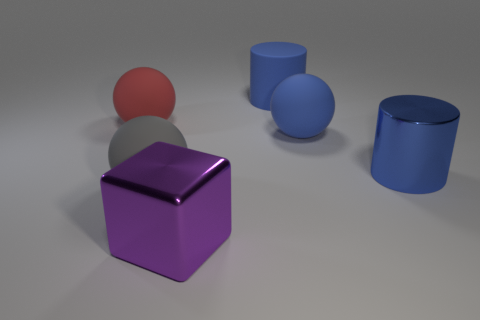Is there anything else that has the same shape as the big purple thing?
Your answer should be very brief. No. Are there fewer matte objects that are behind the big red matte object than large cubes in front of the big purple metallic thing?
Ensure brevity in your answer.  No. What number of blue cylinders are behind the big blue rubber ball?
Offer a very short reply. 1. There is a big shiny object behind the purple shiny object; is its shape the same as the large red rubber object that is behind the purple object?
Provide a short and direct response. No. What number of other objects are the same color as the metallic cylinder?
Provide a succinct answer. 2. There is a sphere that is in front of the big blue cylinder that is on the right side of the large sphere that is on the right side of the purple cube; what is its material?
Provide a short and direct response. Rubber. What material is the sphere on the right side of the blue cylinder that is left of the shiny cylinder?
Provide a succinct answer. Rubber. Is the number of blue matte things that are on the left side of the purple thing less than the number of purple things?
Ensure brevity in your answer.  Yes. There is a thing that is in front of the gray thing; what shape is it?
Offer a terse response. Cube. There is a purple thing; is it the same size as the blue cylinder that is behind the big red ball?
Give a very brief answer. Yes. 